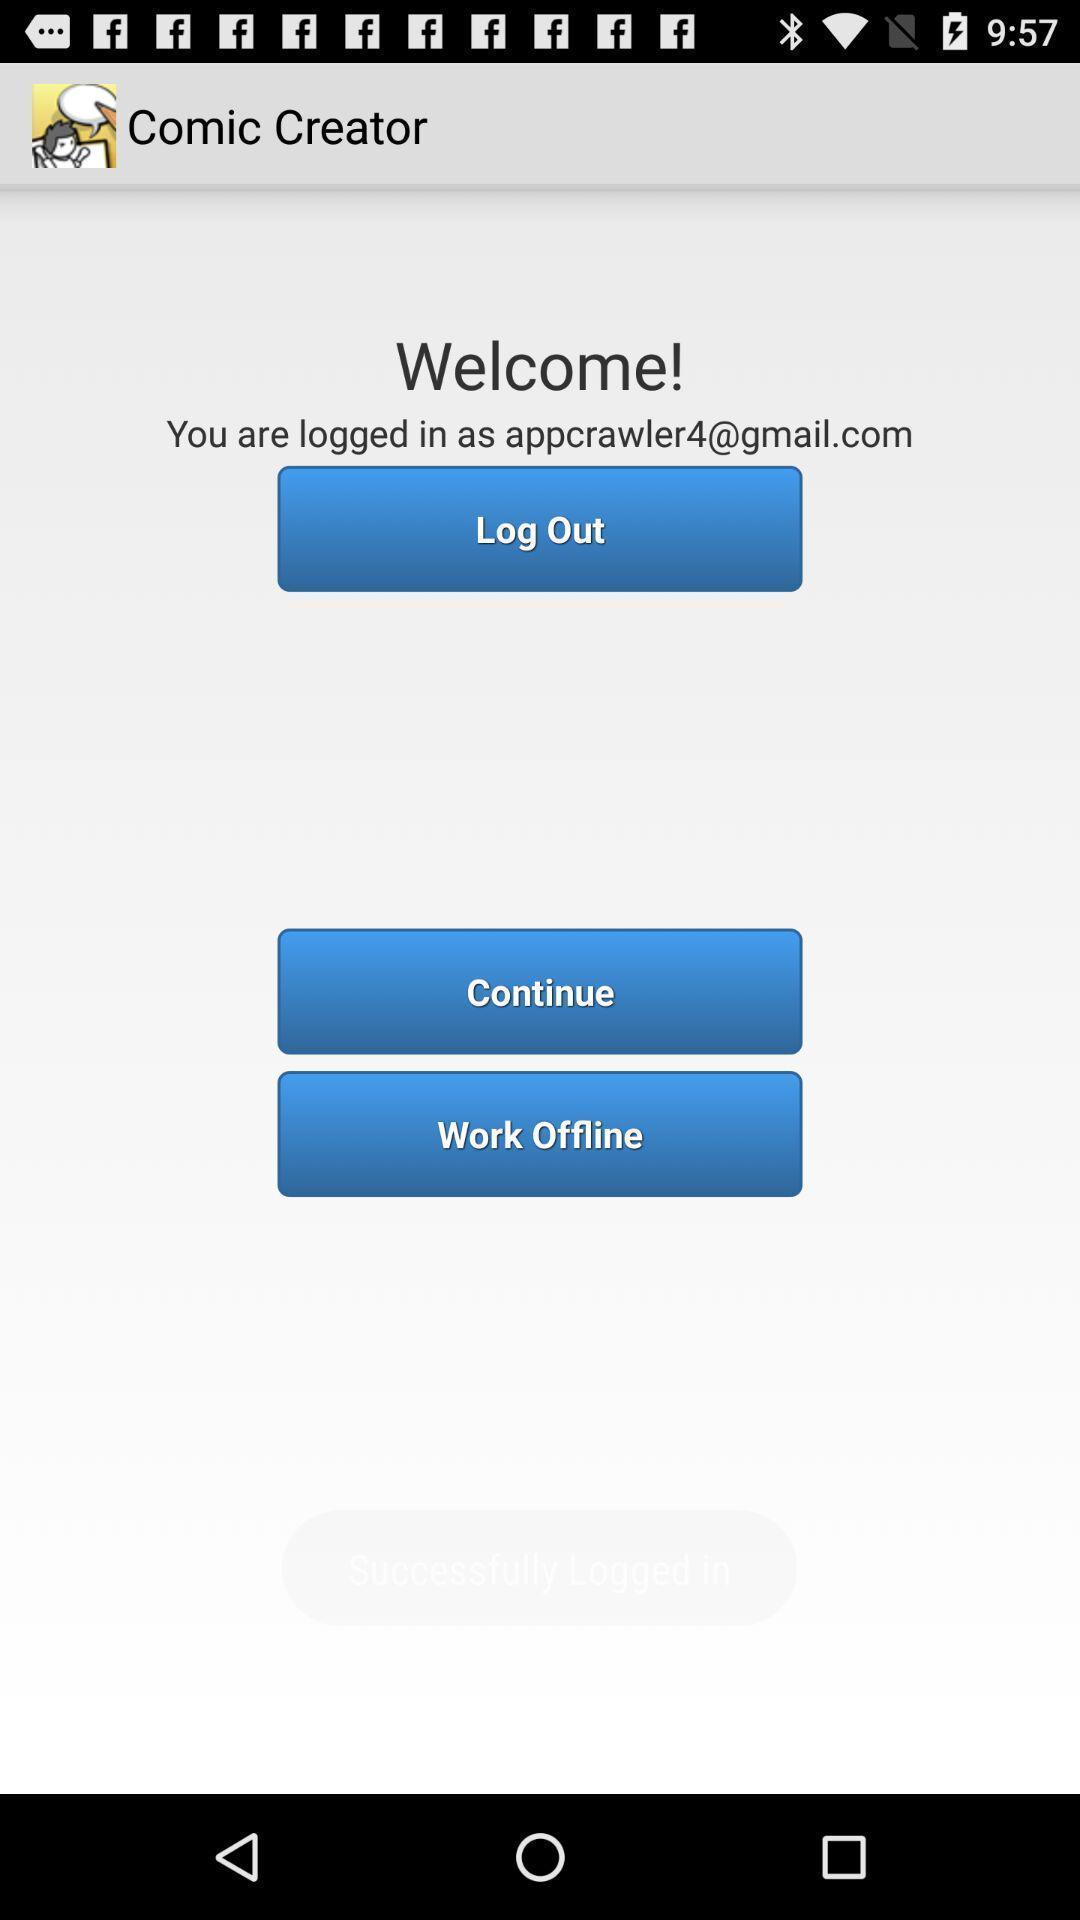Describe the visual elements of this screenshot. Welcome page of cartoon and meme app. 